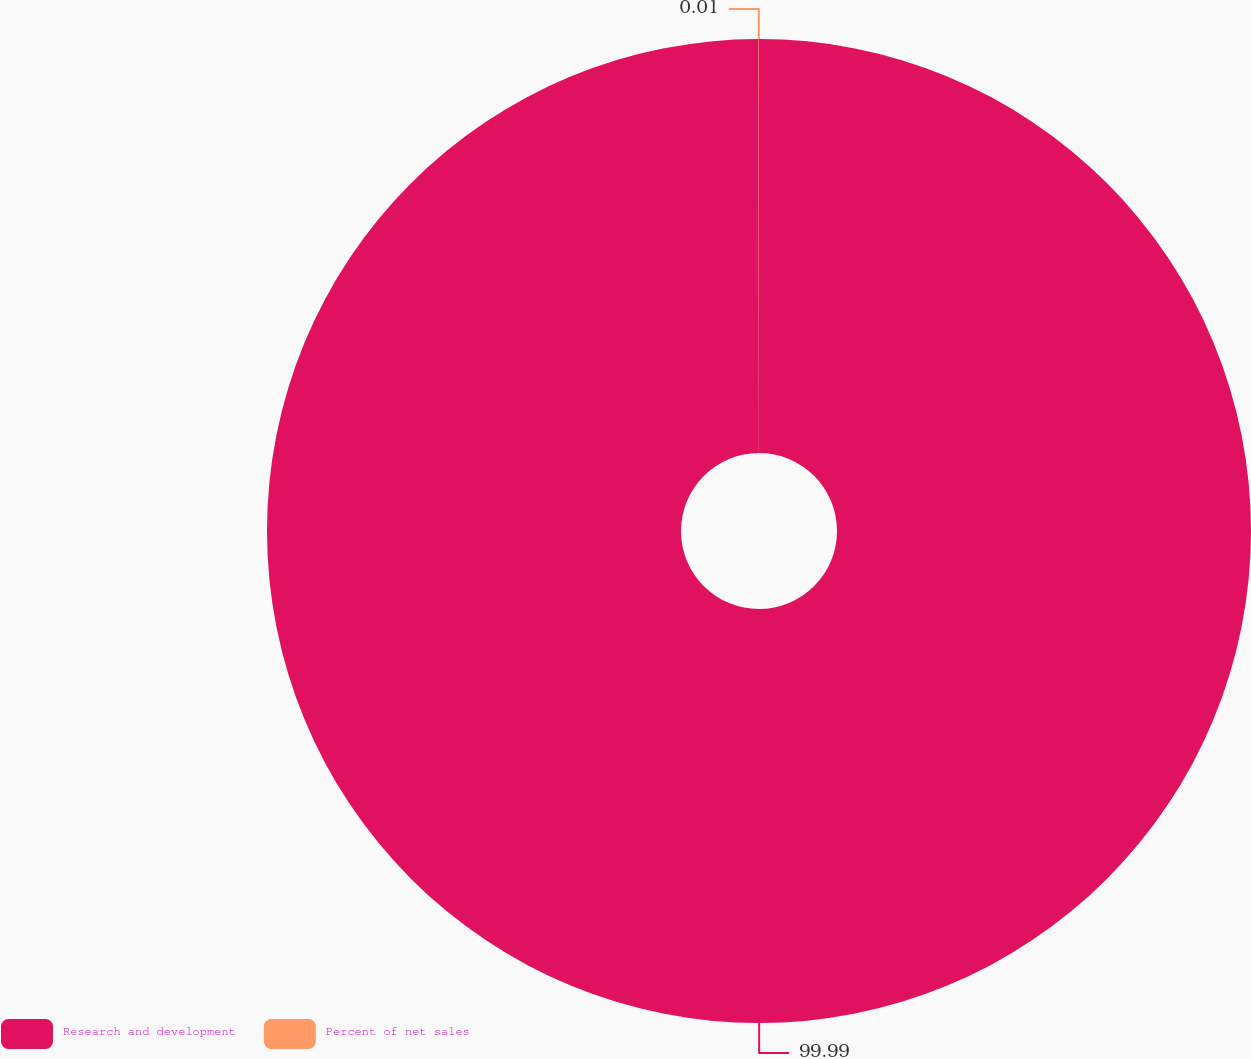Convert chart. <chart><loc_0><loc_0><loc_500><loc_500><pie_chart><fcel>Research and development<fcel>Percent of net sales<nl><fcel>99.99%<fcel>0.01%<nl></chart> 